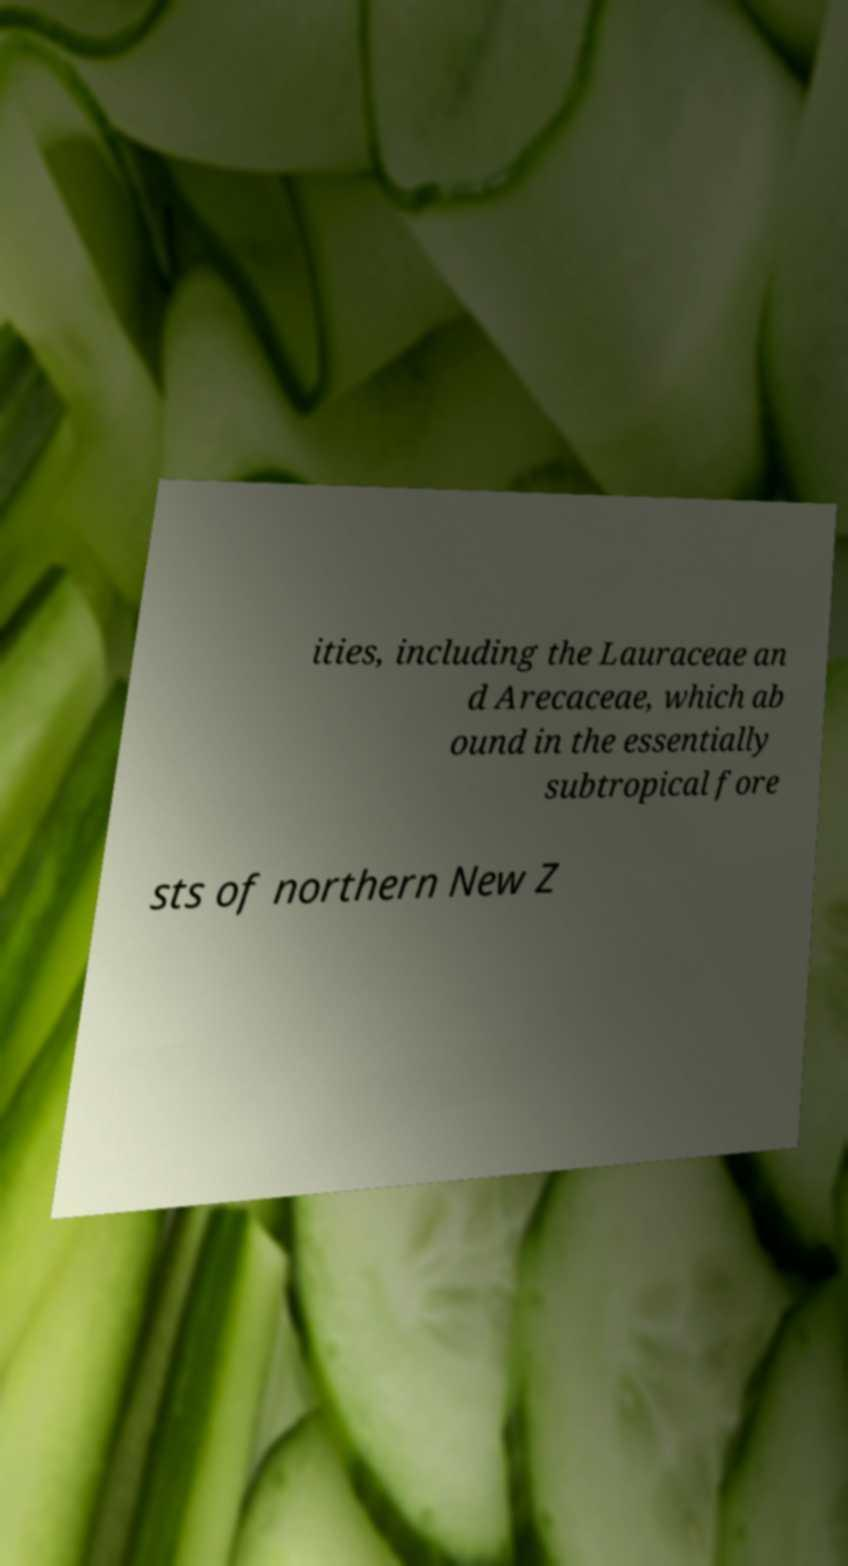Could you extract and type out the text from this image? ities, including the Lauraceae an d Arecaceae, which ab ound in the essentially subtropical fore sts of northern New Z 